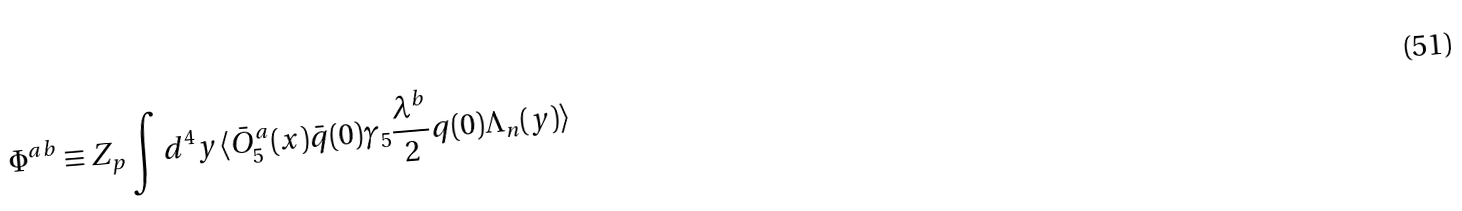<formula> <loc_0><loc_0><loc_500><loc_500>\Phi ^ { a b } \equiv Z _ { p } \int d ^ { 4 } y \langle \bar { O } _ { 5 } ^ { a } ( x ) \bar { q } ( 0 ) \gamma _ { 5 } \frac { \lambda ^ { b } } { 2 } q ( 0 ) \Lambda _ { n } ( y ) \rangle</formula> 